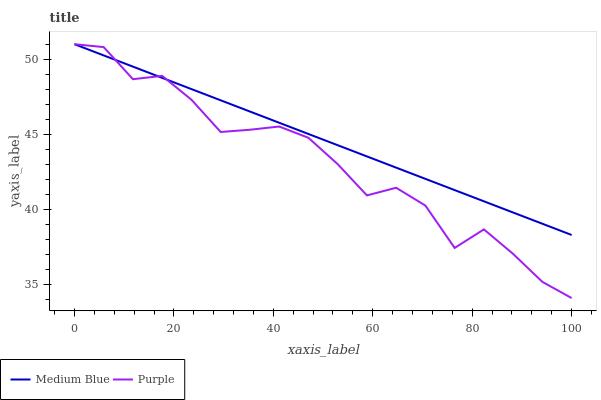Does Purple have the minimum area under the curve?
Answer yes or no. Yes. Does Medium Blue have the maximum area under the curve?
Answer yes or no. Yes. Does Medium Blue have the minimum area under the curve?
Answer yes or no. No. Is Medium Blue the smoothest?
Answer yes or no. Yes. Is Purple the roughest?
Answer yes or no. Yes. Is Medium Blue the roughest?
Answer yes or no. No. Does Purple have the lowest value?
Answer yes or no. Yes. Does Medium Blue have the lowest value?
Answer yes or no. No. Does Medium Blue have the highest value?
Answer yes or no. Yes. Does Purple intersect Medium Blue?
Answer yes or no. Yes. Is Purple less than Medium Blue?
Answer yes or no. No. Is Purple greater than Medium Blue?
Answer yes or no. No. 